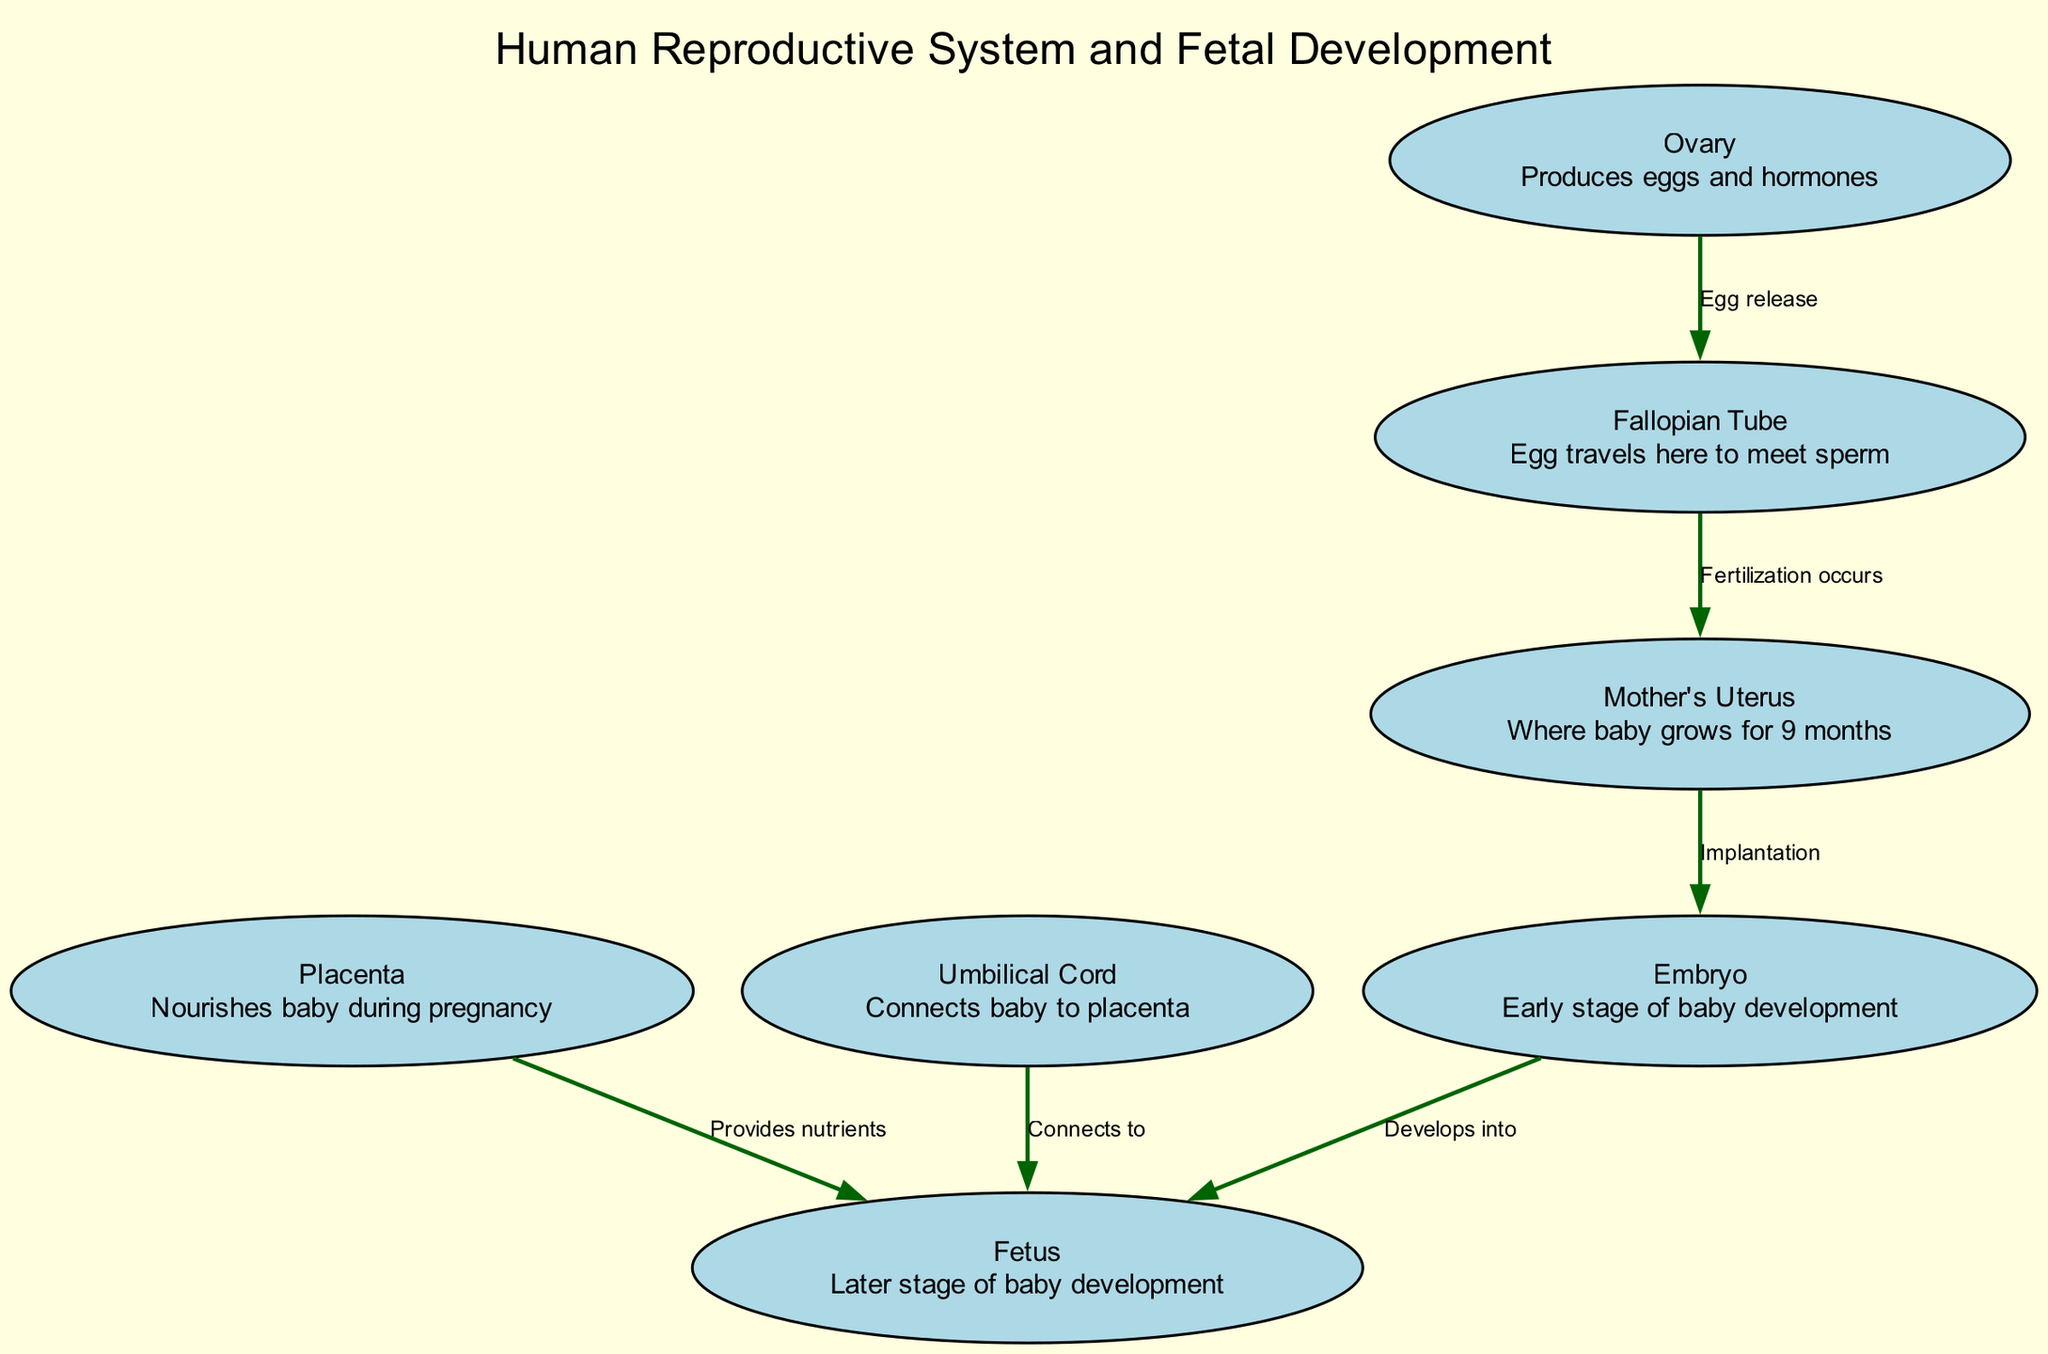What is the first stage of baby development shown in the diagram? The diagram indicates that the first stage of baby development is labeled as "Embryo." This is derived from the node connected to the "Implantation," where the baby starts its early development after being implanted in the mother's uterus.
Answer: Embryo How does the egg travel from the ovary to the uterus? According to the diagram, the egg travels from the "Ovary" to the "Fallopian Tube" where it meets the sperm, and then the fertilized egg moves to the "Mother's Uterus" for implantation. The connection is labeled as "Fertilization occurs" between the Fallopian Tube and the Mother’s Uterus.
Answer: Fallopian Tube How many nodes are present in the diagram? The diagram has a total of 7 nodes listed that represent various components of the human reproductive system and fetal development stages, including the uterus, ovary, and embryo among others.
Answer: 7 What structure provides nourishment to the baby during pregnancy? The diagram shows that the "Placenta" is responsible for nourishing the baby during pregnancy. This is indicated by the edge labeled "Provides nutrients" connecting the placenta to the fetus.
Answer: Placenta What connects the baby to the placenta? The diagram clearly illustrates that the "Umbilical Cord" connects the baby to the placenta. This connection is indicated by the labeled edge "Connects to" between the umbilical cord and the fetus.
Answer: Umbilical Cord What is the relationship between the embryo and fetus stages? The diagram indicates that the embryo "Develops into" a fetus. This relationship is shown through the edge that connects the "Embryo" node to the "Fetus" node, indicating progression in the developmental stages.
Answer: Develops into What role does the mother's uterus play in fetal development? The diagram specifies that the "Mother's Uterus" is where the baby grows for 9 months. This is described in the node directly, indicating its critical function during pregnancy.
Answer: Where baby grows for 9 months 